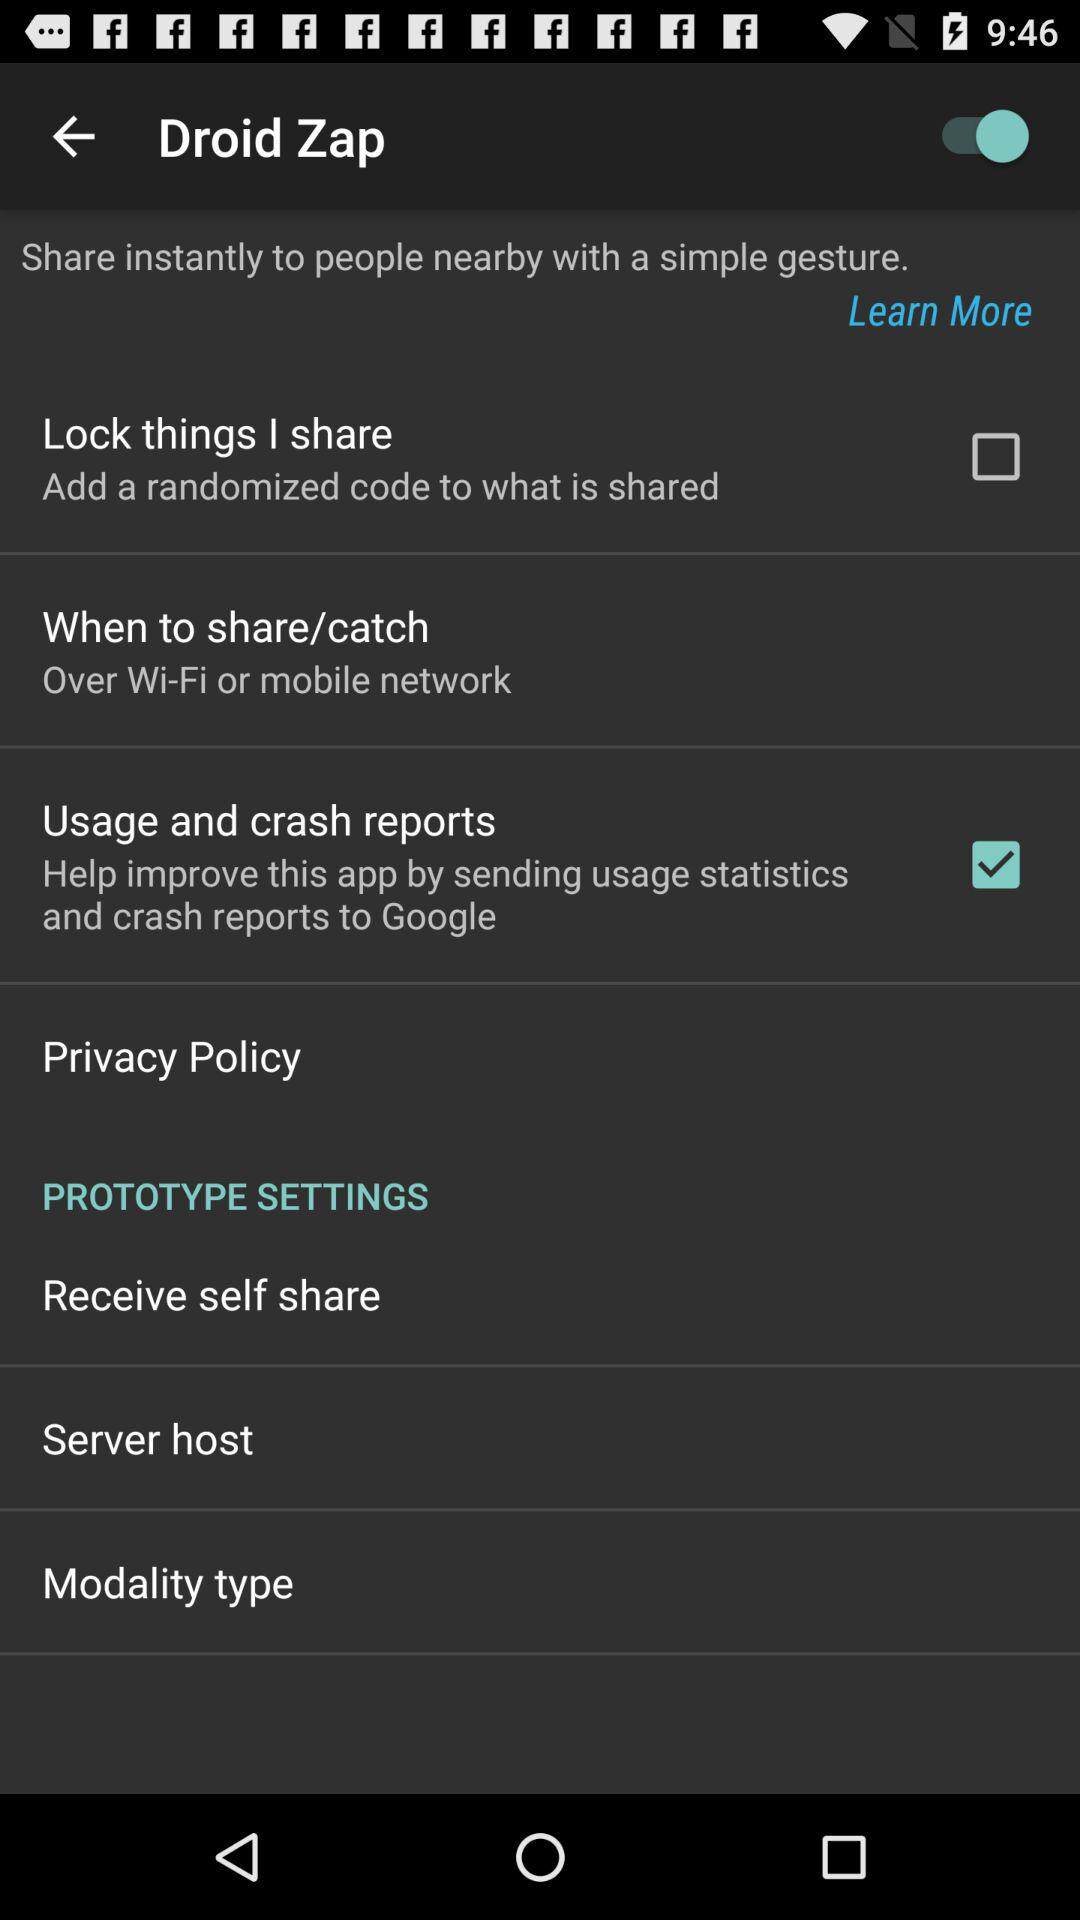What is the status of the "Usage and crash reports"? The status of the "Usage and crash reports" is "on". 